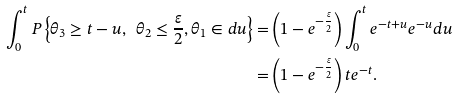Convert formula to latex. <formula><loc_0><loc_0><loc_500><loc_500>\int ^ { t } _ { 0 } { P \left \{ { \theta } _ { 3 } \geq t - u , \ { \theta } _ { 2 } \leq \frac { \varepsilon } { 2 } , { \theta } _ { 1 } \in d u \right \} } = & \left ( 1 - e ^ { - \frac { \varepsilon } { 2 } } \right ) \int ^ { t } _ { 0 } { e ^ { - t + u } e ^ { - u } d u } \\ = & \left ( 1 - e ^ { - \frac { \varepsilon } { 2 } } \right ) t e ^ { - t } .</formula> 